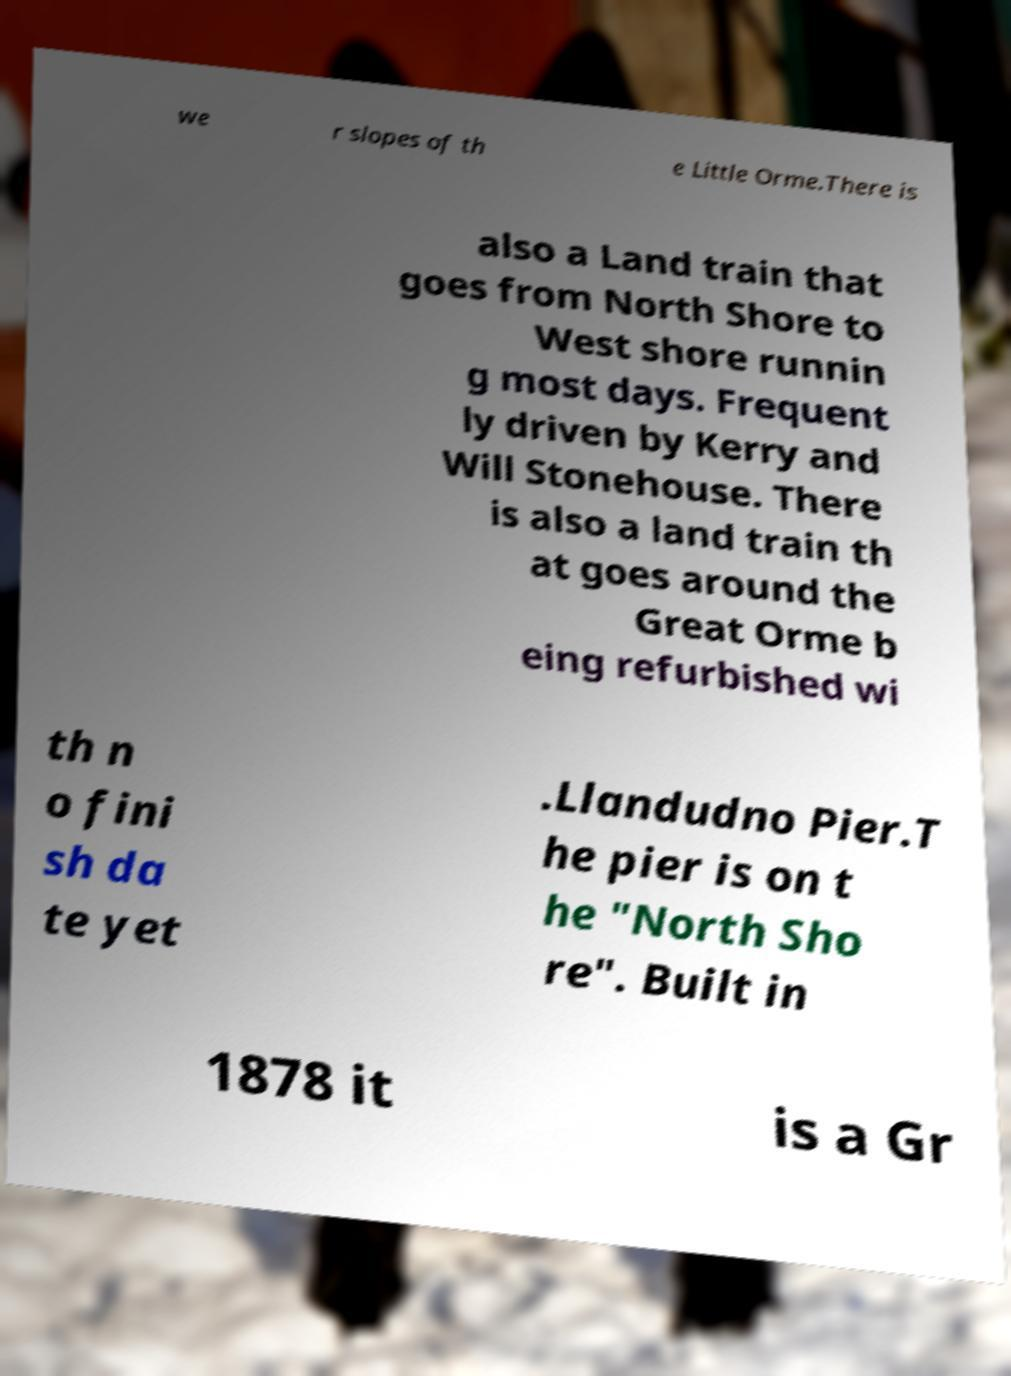Please read and relay the text visible in this image. What does it say? we r slopes of th e Little Orme.There is also a Land train that goes from North Shore to West shore runnin g most days. Frequent ly driven by Kerry and Will Stonehouse. There is also a land train th at goes around the Great Orme b eing refurbished wi th n o fini sh da te yet .Llandudno Pier.T he pier is on t he "North Sho re". Built in 1878 it is a Gr 